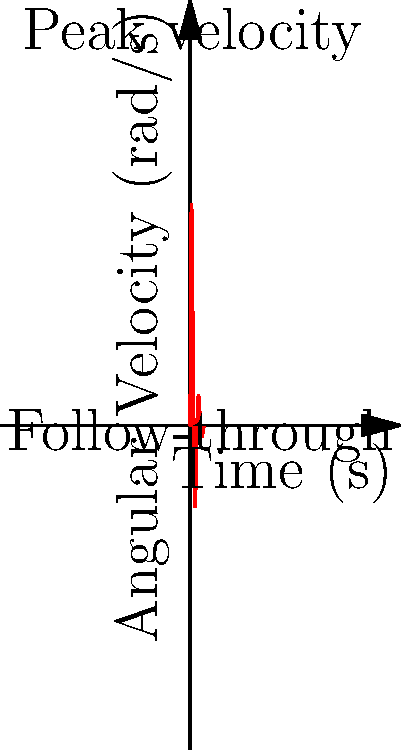During William Stromgrem's wrist shot, the angular velocity of his stick follows the curve shown in the graph. What is the peak angular velocity of the stick during the shot, and at what time does it occur? To analyze the angular velocity of William Stromgrem's stick during a wrist shot, we need to examine the graph carefully:

1. The y-axis represents the angular velocity in radians per second (rad/s).
2. The x-axis represents time in seconds (s).
3. The curve shows how the angular velocity changes over time during the wrist shot.

To find the peak angular velocity:

1. Look for the highest point on the curve.
2. This point occurs at approximately $x = 0.25$ seconds.
3. The y-value at this point is about 50 rad/s.

Therefore:
- The peak angular velocity is approximately 50 rad/s.
- It occurs at about 0.25 seconds into the shot.

This rapid increase and decrease in angular velocity is characteristic of a well-executed wrist shot, where the player quickly accelerates the stick and then decelerates through contact with the puck and follow-through.
Answer: 50 rad/s at 0.25 seconds 